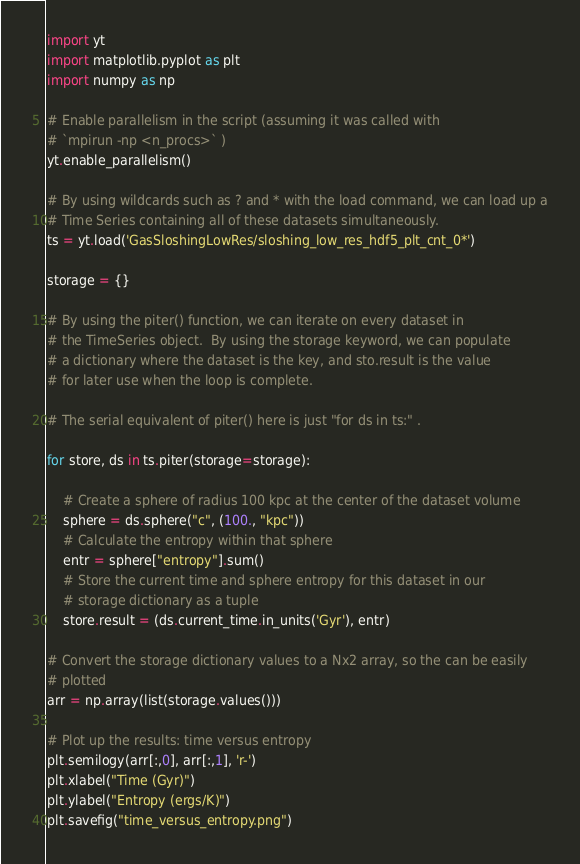<code> <loc_0><loc_0><loc_500><loc_500><_Python_>import yt
import matplotlib.pyplot as plt
import numpy as np

# Enable parallelism in the script (assuming it was called with
# `mpirun -np <n_procs>` )
yt.enable_parallelism()

# By using wildcards such as ? and * with the load command, we can load up a
# Time Series containing all of these datasets simultaneously.
ts = yt.load('GasSloshingLowRes/sloshing_low_res_hdf5_plt_cnt_0*')

storage = {}

# By using the piter() function, we can iterate on every dataset in
# the TimeSeries object.  By using the storage keyword, we can populate
# a dictionary where the dataset is the key, and sto.result is the value
# for later use when the loop is complete.

# The serial equivalent of piter() here is just "for ds in ts:" .

for store, ds in ts.piter(storage=storage):

    # Create a sphere of radius 100 kpc at the center of the dataset volume
    sphere = ds.sphere("c", (100., "kpc"))
    # Calculate the entropy within that sphere
    entr = sphere["entropy"].sum()
    # Store the current time and sphere entropy for this dataset in our
    # storage dictionary as a tuple
    store.result = (ds.current_time.in_units('Gyr'), entr)

# Convert the storage dictionary values to a Nx2 array, so the can be easily
# plotted
arr = np.array(list(storage.values()))

# Plot up the results: time versus entropy
plt.semilogy(arr[:,0], arr[:,1], 'r-')
plt.xlabel("Time (Gyr)")
plt.ylabel("Entropy (ergs/K)")
plt.savefig("time_versus_entropy.png")
</code> 